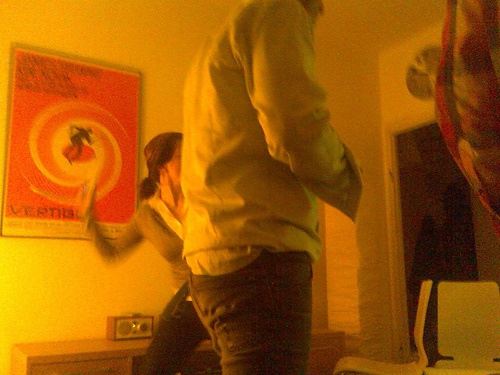Describe the objects in this image and their specific colors. I can see people in orange, maroon, and brown tones, people in orange, brown, red, and maroon tones, chair in orange, olive, and maroon tones, chair in orange, olive, and maroon tones, and clock in orange, brown, and maroon tones in this image. 